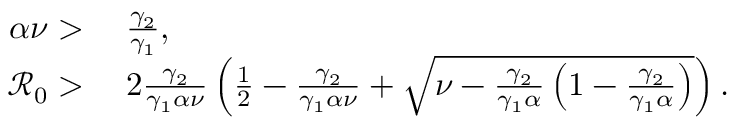<formula> <loc_0><loc_0><loc_500><loc_500>\begin{array} { r l } { \alpha \nu > } & { \, \frac { \gamma _ { 2 } } { \gamma _ { 1 } } , } \\ { \mathcal { R } _ { 0 } > } & { \, 2 \frac { \gamma _ { 2 } } { \gamma _ { 1 } \alpha \nu } \left ( \frac { 1 } { 2 } - \frac { \gamma _ { 2 } } { \gamma _ { 1 } \alpha \nu } + \sqrt { \nu - \frac { \gamma _ { 2 } } { \gamma _ { 1 } \alpha } \left ( 1 - \frac { \gamma _ { 2 } } { \gamma _ { 1 } \alpha } \right ) } \right ) . } \end{array}</formula> 